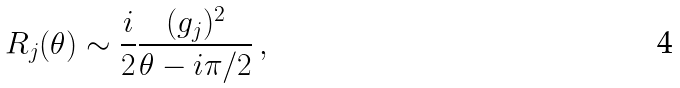Convert formula to latex. <formula><loc_0><loc_0><loc_500><loc_500>R _ { j } ( \theta ) \sim \frac { i } { 2 } \frac { ( g _ { j } ) ^ { 2 } } { \theta - i \pi / 2 } \, ,</formula> 